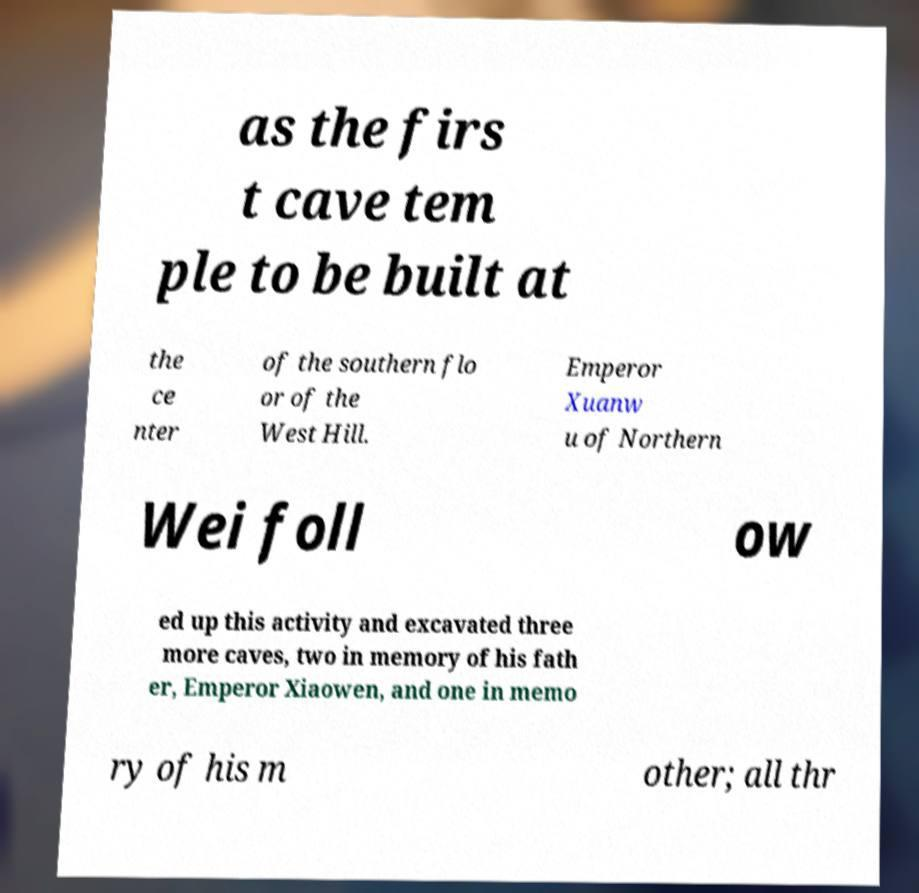Please read and relay the text visible in this image. What does it say? as the firs t cave tem ple to be built at the ce nter of the southern flo or of the West Hill. Emperor Xuanw u of Northern Wei foll ow ed up this activity and excavated three more caves, two in memory of his fath er, Emperor Xiaowen, and one in memo ry of his m other; all thr 